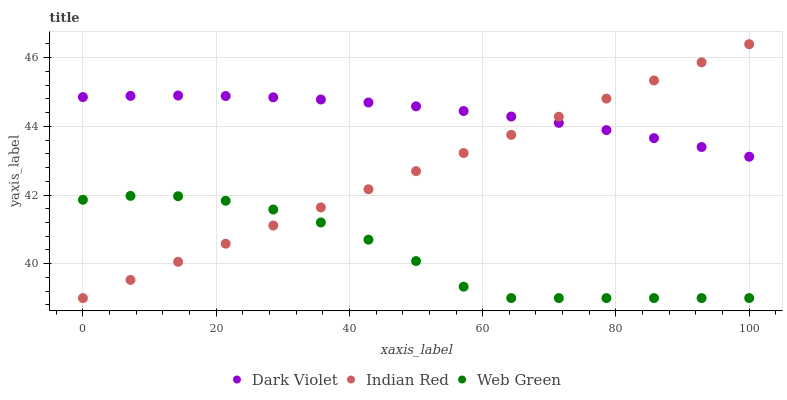Does Web Green have the minimum area under the curve?
Answer yes or no. Yes. Does Dark Violet have the maximum area under the curve?
Answer yes or no. Yes. Does Indian Red have the minimum area under the curve?
Answer yes or no. No. Does Indian Red have the maximum area under the curve?
Answer yes or no. No. Is Indian Red the smoothest?
Answer yes or no. Yes. Is Web Green the roughest?
Answer yes or no. Yes. Is Dark Violet the smoothest?
Answer yes or no. No. Is Dark Violet the roughest?
Answer yes or no. No. Does Web Green have the lowest value?
Answer yes or no. Yes. Does Dark Violet have the lowest value?
Answer yes or no. No. Does Indian Red have the highest value?
Answer yes or no. Yes. Does Dark Violet have the highest value?
Answer yes or no. No. Is Web Green less than Dark Violet?
Answer yes or no. Yes. Is Dark Violet greater than Web Green?
Answer yes or no. Yes. Does Dark Violet intersect Indian Red?
Answer yes or no. Yes. Is Dark Violet less than Indian Red?
Answer yes or no. No. Is Dark Violet greater than Indian Red?
Answer yes or no. No. Does Web Green intersect Dark Violet?
Answer yes or no. No. 